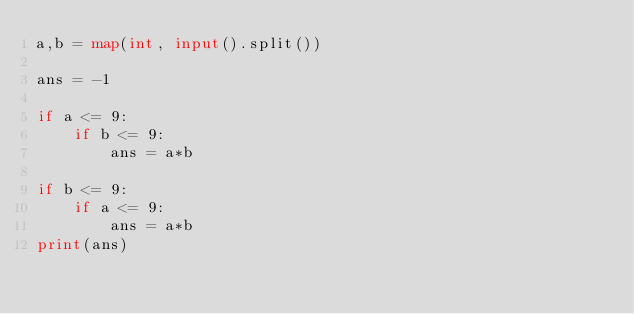<code> <loc_0><loc_0><loc_500><loc_500><_Python_>a,b = map(int, input().split())

ans = -1

if a <= 9:
    if b <= 9:
        ans = a*b

if b <= 9:
    if a <= 9:
        ans = a*b
print(ans)

</code> 